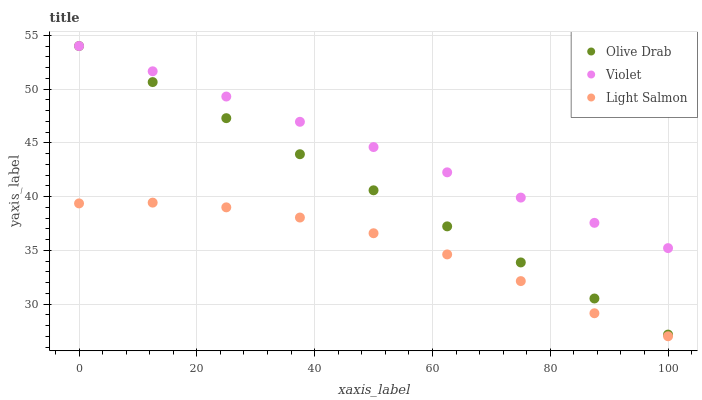Does Light Salmon have the minimum area under the curve?
Answer yes or no. Yes. Does Violet have the maximum area under the curve?
Answer yes or no. Yes. Does Olive Drab have the minimum area under the curve?
Answer yes or no. No. Does Olive Drab have the maximum area under the curve?
Answer yes or no. No. Is Olive Drab the smoothest?
Answer yes or no. Yes. Is Light Salmon the roughest?
Answer yes or no. Yes. Is Violet the smoothest?
Answer yes or no. No. Is Violet the roughest?
Answer yes or no. No. Does Light Salmon have the lowest value?
Answer yes or no. Yes. Does Olive Drab have the lowest value?
Answer yes or no. No. Does Violet have the highest value?
Answer yes or no. Yes. Is Light Salmon less than Violet?
Answer yes or no. Yes. Is Olive Drab greater than Light Salmon?
Answer yes or no. Yes. Does Olive Drab intersect Violet?
Answer yes or no. Yes. Is Olive Drab less than Violet?
Answer yes or no. No. Is Olive Drab greater than Violet?
Answer yes or no. No. Does Light Salmon intersect Violet?
Answer yes or no. No. 